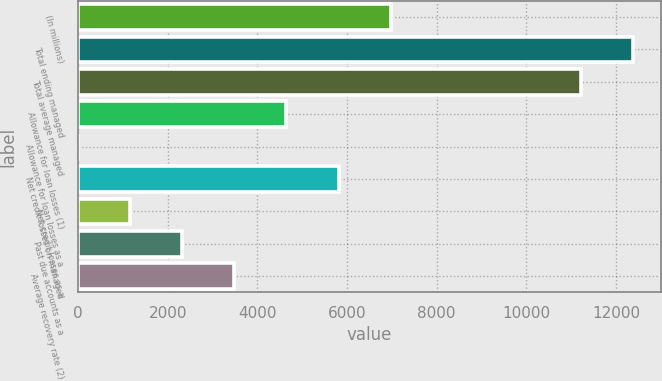Convert chart. <chart><loc_0><loc_0><loc_500><loc_500><bar_chart><fcel>(In millions)<fcel>Total ending managed<fcel>Total average managed<fcel>Allowance for loan losses (1)<fcel>Allowance for loan losses as a<fcel>Net credit losses on managed<fcel>Net credit losses as a<fcel>Past due accounts as a<fcel>Average recovery rate (2)<nl><fcel>6971.79<fcel>12372.6<fcel>11210.8<fcel>4648.23<fcel>1.11<fcel>5810.01<fcel>1162.89<fcel>2324.67<fcel>3486.45<nl></chart> 